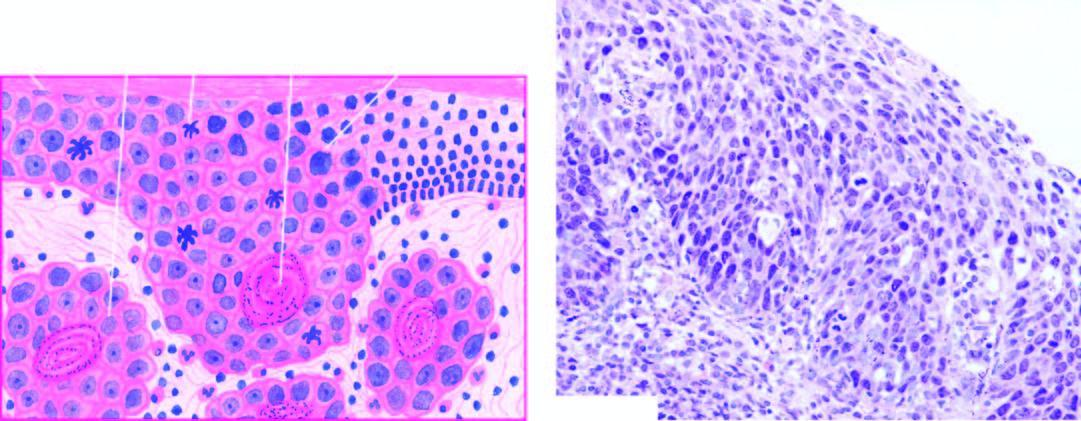s there keratosis, irregular stratification, cellular pleomorphism, increased and abnormal mitotic figures and individual cell keratinisation, while a few areas show superficial invasive islands of malignant cells in the subepithelial soft tissues?
Answer the question using a single word or phrase. Yes 